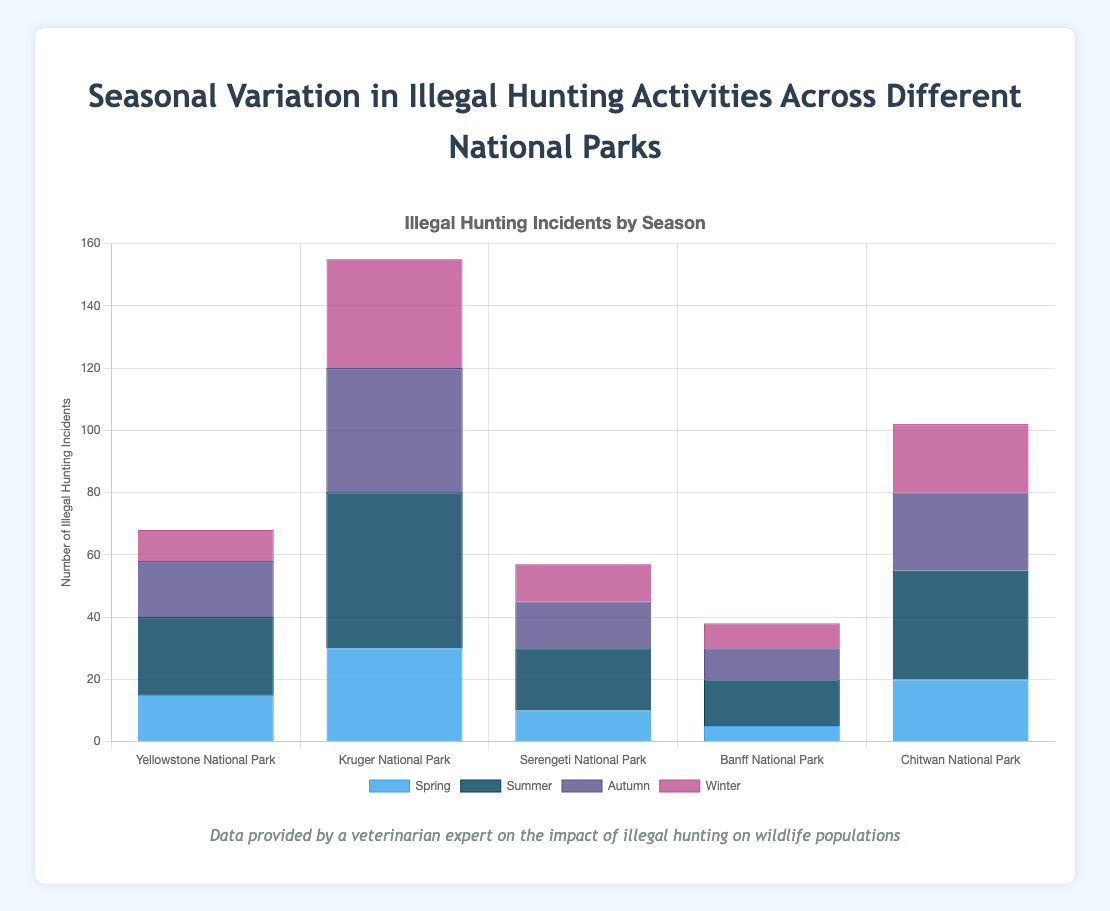What season has the highest number of illegal hunting incidents in Kruger National Park? Observe the height of the bars corresponding to each season for Kruger National Park. The tallest bar indicates the highest number. The dark blue bar for Summer is the tallest.
Answer: Summer Which national park has the most illegal hunting incidents in the winter? Compare the heights of the winter bars across all national parks. The tallest bar indicates the highest number. The dark purple bar for Kruger National Park is the tallest.
Answer: Kruger National Park What is the difference in illegal hunting incidents between Summer and Winter in Yellowstone National Park? Identify and subtract the values of the Summer and Winter bars for Yellowstone National Park. (25 - 10).
Answer: 15 Which season has the least illegal hunting incidents in Serengeti National Park? Observe the height of the bars corresponding to each season for Serengeti National Park. The shortest bar indicates the least number. The light blue bar for Spring is the shortest.
Answer: Spring What is the total number of illegal hunting incidents in Chitwan National Park across all seasons? Sum the values of all bars for Chitwan National Park. (20 Spring + 35 Summer + 25 Autumn + 22 Winter).
Answer: 102 Which national park experiences the greatest seasonal variation in illegal hunting incidents? Calculate the range (max value - min value) of illegal hunting incidents for each park and determine the one with the greatest range. Kruger National Park has the greatest variation with a range (50 - 30).
Answer: Kruger National Park In which season does illegal hunting incidents consistently peak across most national parks? Identify the tallest bar for each park and note the season it corresponds to. Most parks have their tallest bar in Summer.
Answer: Summer How does the summer illegal hunting incidents in Banff National Park compare with spring incidents in Kruger National Park? Compare the heights of the summer bar in Banff to the spring bar in Kruger. Kruger in Spring (light blue) is much taller than Banff in Summer (dark blue).
Answer: Kruger National Park (Spring is higher) What is the average number of illegal hunting incidents in Yellowstone National Park throughout the year? Sum the values of all bars for Yellowstone and divide by the number of seasons. (15 + 25 + 18 + 10) / 4.
Answer: 17 